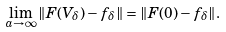Convert formula to latex. <formula><loc_0><loc_0><loc_500><loc_500>\lim _ { a \to \infty } \| F ( V _ { \delta } ) - f _ { \delta } \| = \| F ( 0 ) - f _ { \delta } \| .</formula> 